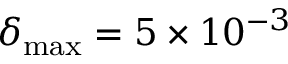Convert formula to latex. <formula><loc_0><loc_0><loc_500><loc_500>\delta _ { \max } = 5 \times 1 0 ^ { - 3 }</formula> 